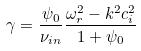<formula> <loc_0><loc_0><loc_500><loc_500>\gamma = \frac { \psi _ { 0 } } { \nu _ { i n } } \frac { \omega _ { r } ^ { 2 } - k ^ { 2 } c _ { i } ^ { 2 } } { 1 + \psi _ { 0 } }</formula> 